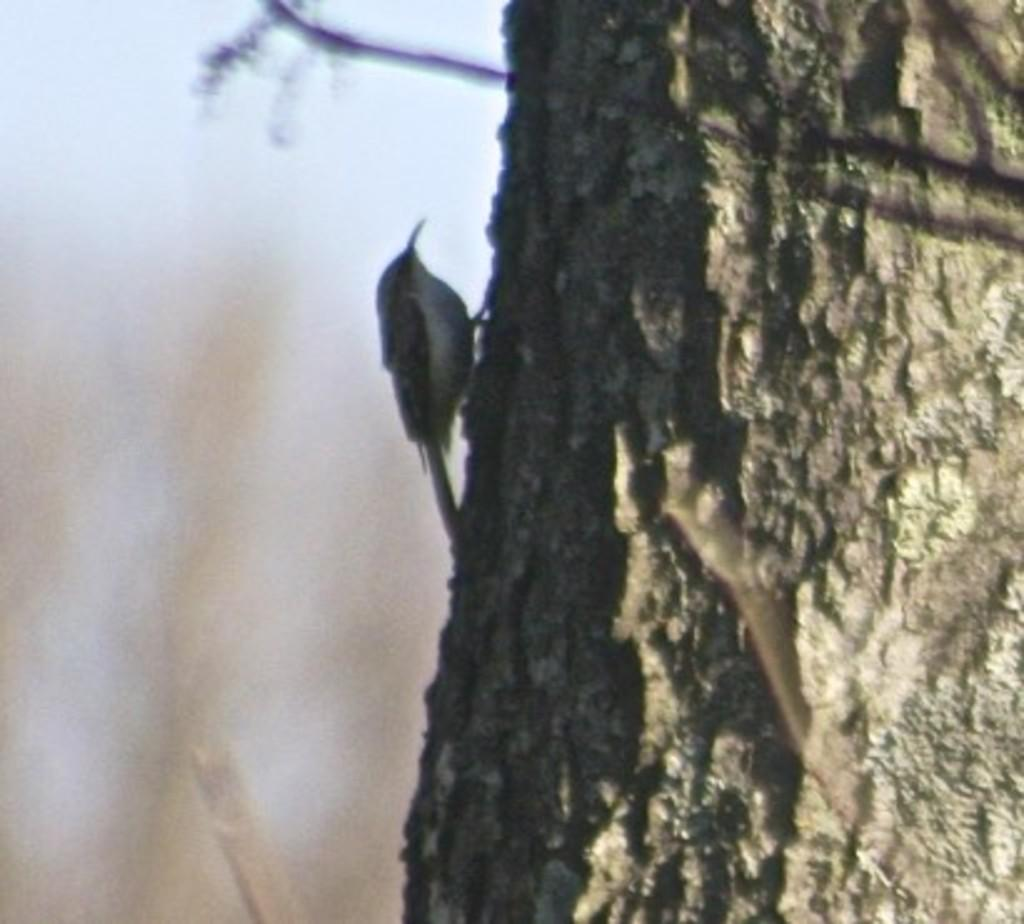What object is the main focus of the image? There is a trunk in the image. Is there any living creature on the trunk? Yes, there is a bird on the trunk. Can you describe the background of the image? The background of the image is blurred. What type of soda is the bird drinking from the trunk in the image? There is no soda present in the image, and the bird is not shown drinking anything. What relation does the bird have with the trunk in the image? The bird is simply perched on the trunk, so there is no specific relation between them. 